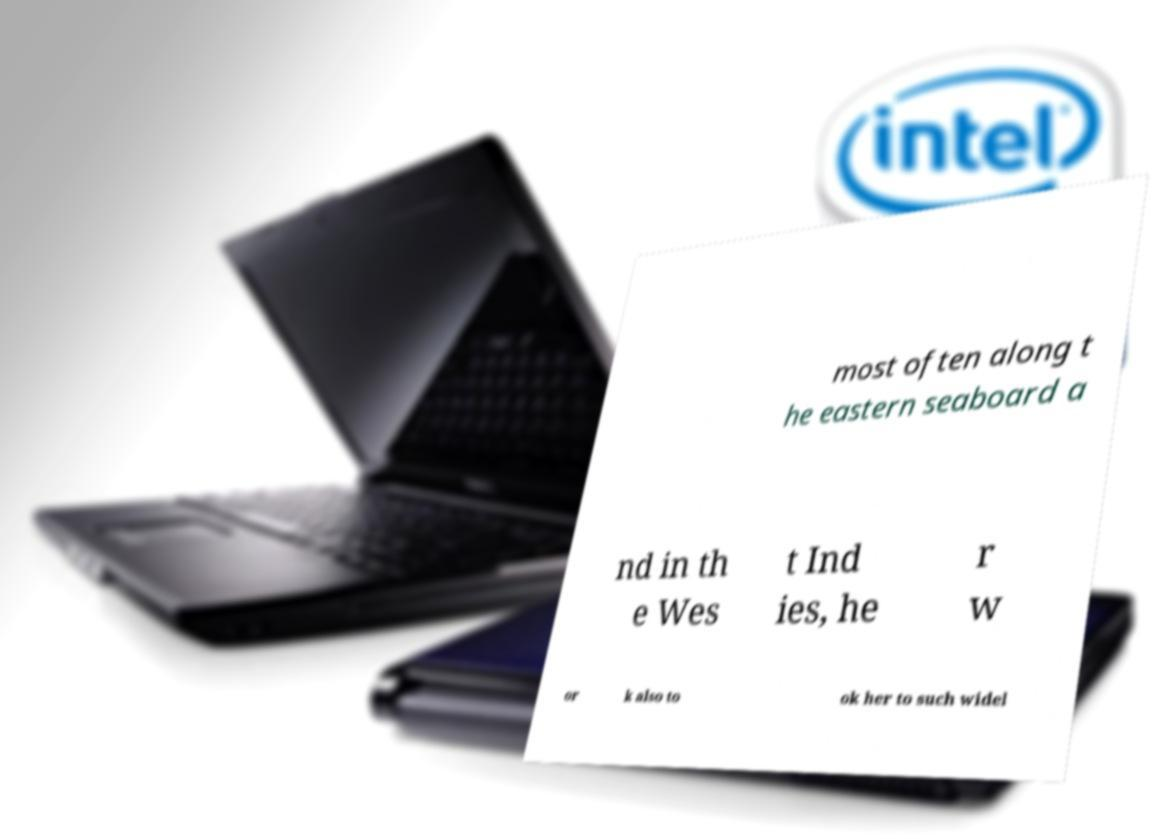I need the written content from this picture converted into text. Can you do that? most often along t he eastern seaboard a nd in th e Wes t Ind ies, he r w or k also to ok her to such widel 